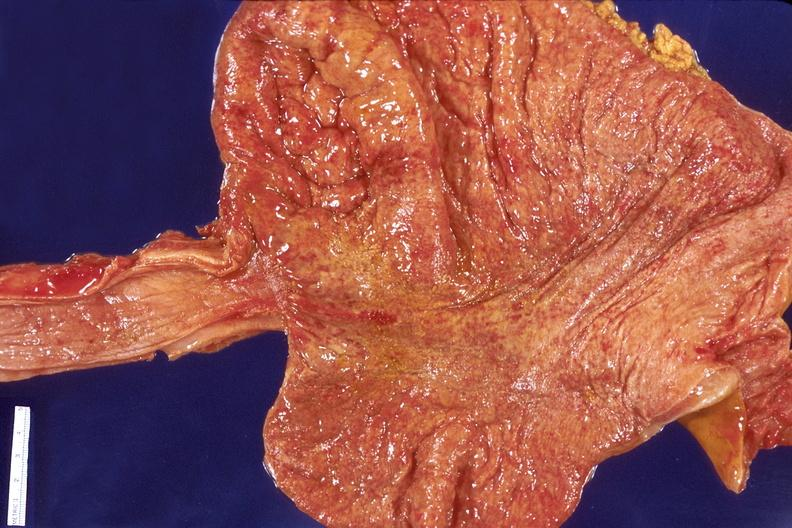does this image show stomach, bacterial gastritis?
Answer the question using a single word or phrase. Yes 